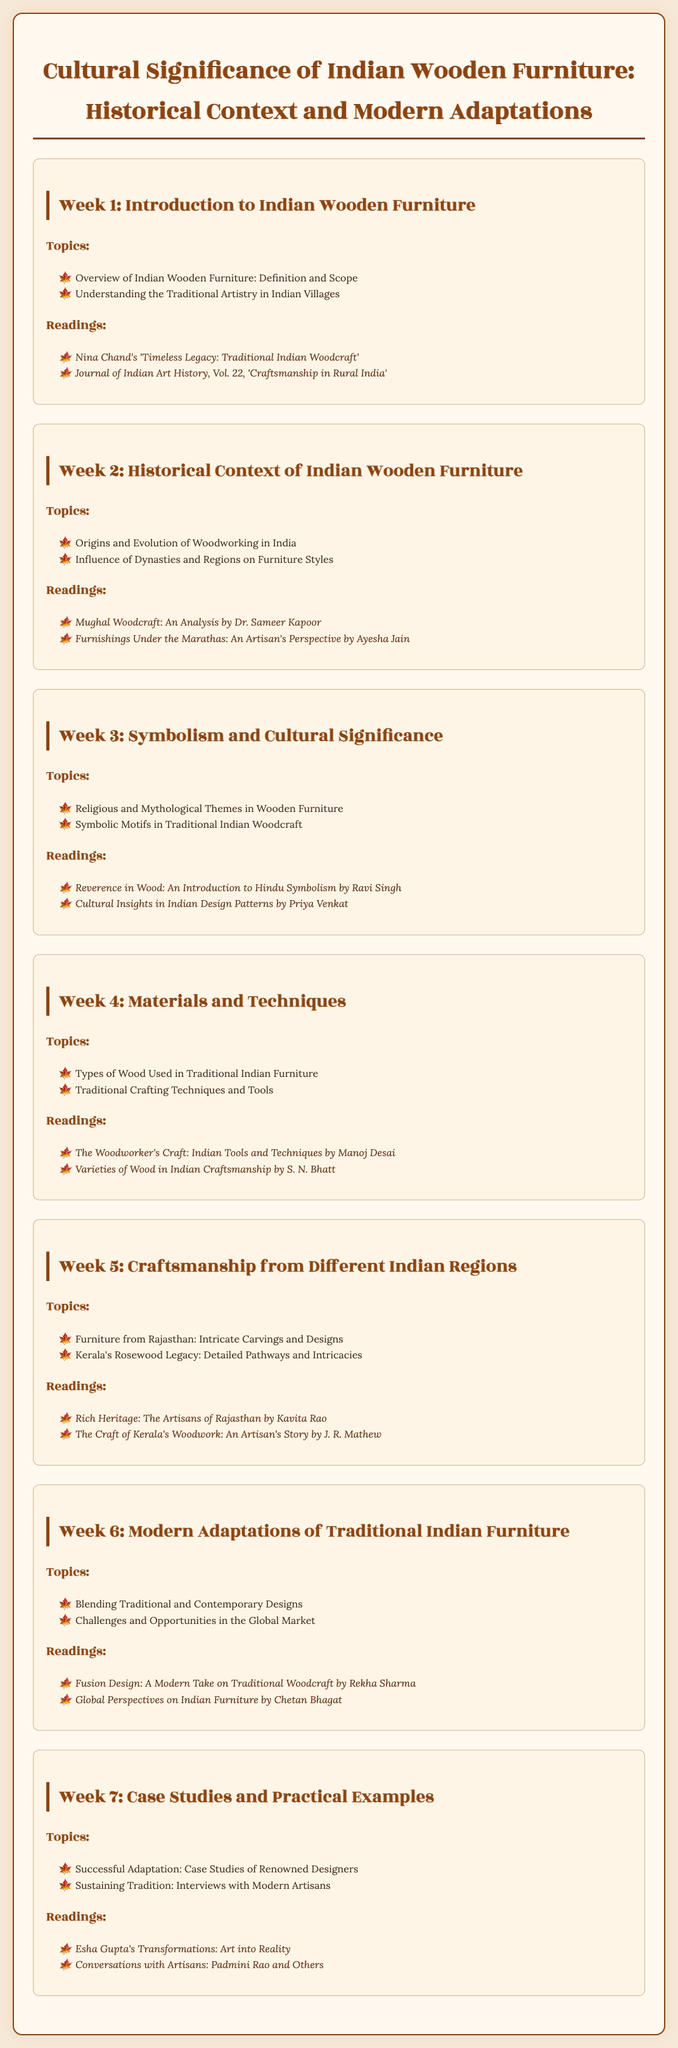What are the main topics in Week 1? The main topics in Week 1 include an overview of Indian Wooden Furniture and understanding the traditional artistry in Indian villages.
Answer: Overview of Indian Wooden Furniture: Definition and Scope; Understanding the Traditional Artistry in Indian Villages Who is the author of "Mughal Woodcraft: An Analysis"? "Mughal Woodcraft: An Analysis" is authored by Dr. Sameer Kapoor.
Answer: Dr. Sameer Kapoor Which week discusses religious and mythological themes? Week 3 focuses on religious and mythological themes in wooden furniture.
Answer: Week 3 What type of wood is highlighted in Kerala's woodworking? Kerala's woodworking emphasizes the use of rosewood.
Answer: Rosewood How many readings are listed in Week 6? Week 6 lists a total of two readings for students.
Answer: 2 What is one challenge mentioned in Week 6? Week 6 discusses challenges in the global market as a key issue.
Answer: Challenges in the Global Market Who authored "Transformations: Art into Reality"? "Transformations: Art into Reality" is authored by Esha Gupta.
Answer: Esha Gupta What type of furniture is noted for intricate carvings from Rajasthan? The furniture from Rajasthan is noted for its intricate carvings and designs.
Answer: Intricate Carvings and Designs 